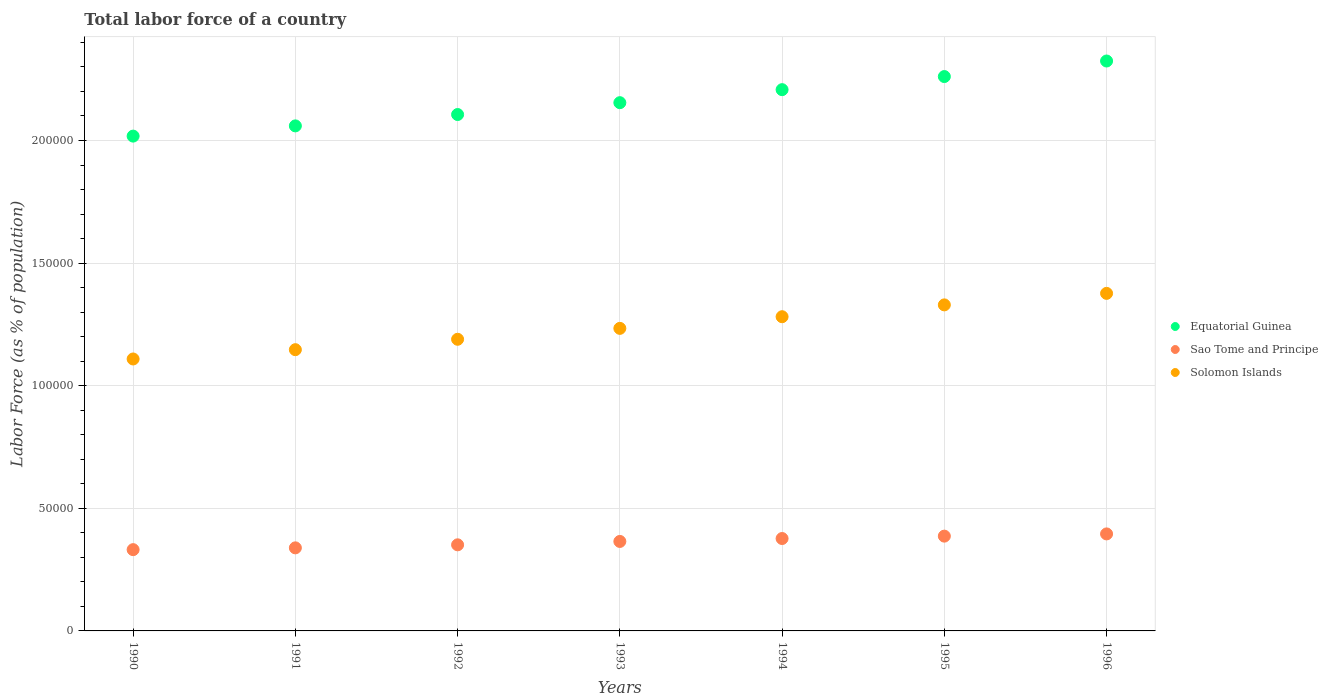How many different coloured dotlines are there?
Give a very brief answer. 3. What is the percentage of labor force in Equatorial Guinea in 1996?
Keep it short and to the point. 2.32e+05. Across all years, what is the maximum percentage of labor force in Solomon Islands?
Your answer should be very brief. 1.38e+05. Across all years, what is the minimum percentage of labor force in Equatorial Guinea?
Your answer should be very brief. 2.02e+05. In which year was the percentage of labor force in Solomon Islands maximum?
Offer a terse response. 1996. In which year was the percentage of labor force in Sao Tome and Principe minimum?
Your response must be concise. 1990. What is the total percentage of labor force in Solomon Islands in the graph?
Your answer should be very brief. 8.67e+05. What is the difference between the percentage of labor force in Equatorial Guinea in 1990 and that in 1994?
Offer a terse response. -1.89e+04. What is the difference between the percentage of labor force in Equatorial Guinea in 1994 and the percentage of labor force in Sao Tome and Principe in 1990?
Ensure brevity in your answer.  1.88e+05. What is the average percentage of labor force in Sao Tome and Principe per year?
Your answer should be very brief. 3.64e+04. In the year 1996, what is the difference between the percentage of labor force in Sao Tome and Principe and percentage of labor force in Solomon Islands?
Your answer should be very brief. -9.81e+04. In how many years, is the percentage of labor force in Sao Tome and Principe greater than 50000 %?
Keep it short and to the point. 0. What is the ratio of the percentage of labor force in Sao Tome and Principe in 1994 to that in 1996?
Ensure brevity in your answer.  0.95. What is the difference between the highest and the second highest percentage of labor force in Sao Tome and Principe?
Ensure brevity in your answer.  905. What is the difference between the highest and the lowest percentage of labor force in Solomon Islands?
Ensure brevity in your answer.  2.68e+04. Is the sum of the percentage of labor force in Solomon Islands in 1993 and 1994 greater than the maximum percentage of labor force in Equatorial Guinea across all years?
Offer a terse response. Yes. Does the percentage of labor force in Equatorial Guinea monotonically increase over the years?
Your answer should be very brief. Yes. Is the percentage of labor force in Sao Tome and Principe strictly less than the percentage of labor force in Solomon Islands over the years?
Provide a succinct answer. Yes. What is the difference between two consecutive major ticks on the Y-axis?
Offer a terse response. 5.00e+04. Are the values on the major ticks of Y-axis written in scientific E-notation?
Keep it short and to the point. No. Does the graph contain any zero values?
Make the answer very short. No. Does the graph contain grids?
Give a very brief answer. Yes. Where does the legend appear in the graph?
Your answer should be compact. Center right. What is the title of the graph?
Give a very brief answer. Total labor force of a country. Does "Slovenia" appear as one of the legend labels in the graph?
Your answer should be very brief. No. What is the label or title of the Y-axis?
Provide a short and direct response. Labor Force (as % of population). What is the Labor Force (as % of population) in Equatorial Guinea in 1990?
Make the answer very short. 2.02e+05. What is the Labor Force (as % of population) in Sao Tome and Principe in 1990?
Offer a terse response. 3.31e+04. What is the Labor Force (as % of population) in Solomon Islands in 1990?
Give a very brief answer. 1.11e+05. What is the Labor Force (as % of population) in Equatorial Guinea in 1991?
Provide a succinct answer. 2.06e+05. What is the Labor Force (as % of population) of Sao Tome and Principe in 1991?
Ensure brevity in your answer.  3.39e+04. What is the Labor Force (as % of population) of Solomon Islands in 1991?
Your answer should be compact. 1.15e+05. What is the Labor Force (as % of population) in Equatorial Guinea in 1992?
Provide a short and direct response. 2.11e+05. What is the Labor Force (as % of population) in Sao Tome and Principe in 1992?
Keep it short and to the point. 3.51e+04. What is the Labor Force (as % of population) in Solomon Islands in 1992?
Offer a terse response. 1.19e+05. What is the Labor Force (as % of population) of Equatorial Guinea in 1993?
Offer a very short reply. 2.15e+05. What is the Labor Force (as % of population) of Sao Tome and Principe in 1993?
Offer a terse response. 3.65e+04. What is the Labor Force (as % of population) in Solomon Islands in 1993?
Your answer should be compact. 1.23e+05. What is the Labor Force (as % of population) of Equatorial Guinea in 1994?
Give a very brief answer. 2.21e+05. What is the Labor Force (as % of population) of Sao Tome and Principe in 1994?
Provide a short and direct response. 3.77e+04. What is the Labor Force (as % of population) of Solomon Islands in 1994?
Your answer should be very brief. 1.28e+05. What is the Labor Force (as % of population) in Equatorial Guinea in 1995?
Provide a short and direct response. 2.26e+05. What is the Labor Force (as % of population) in Sao Tome and Principe in 1995?
Make the answer very short. 3.87e+04. What is the Labor Force (as % of population) of Solomon Islands in 1995?
Make the answer very short. 1.33e+05. What is the Labor Force (as % of population) of Equatorial Guinea in 1996?
Keep it short and to the point. 2.32e+05. What is the Labor Force (as % of population) in Sao Tome and Principe in 1996?
Provide a succinct answer. 3.96e+04. What is the Labor Force (as % of population) of Solomon Islands in 1996?
Your answer should be compact. 1.38e+05. Across all years, what is the maximum Labor Force (as % of population) in Equatorial Guinea?
Offer a terse response. 2.32e+05. Across all years, what is the maximum Labor Force (as % of population) of Sao Tome and Principe?
Ensure brevity in your answer.  3.96e+04. Across all years, what is the maximum Labor Force (as % of population) of Solomon Islands?
Keep it short and to the point. 1.38e+05. Across all years, what is the minimum Labor Force (as % of population) of Equatorial Guinea?
Your response must be concise. 2.02e+05. Across all years, what is the minimum Labor Force (as % of population) in Sao Tome and Principe?
Your answer should be compact. 3.31e+04. Across all years, what is the minimum Labor Force (as % of population) in Solomon Islands?
Offer a very short reply. 1.11e+05. What is the total Labor Force (as % of population) in Equatorial Guinea in the graph?
Offer a very short reply. 1.51e+06. What is the total Labor Force (as % of population) of Sao Tome and Principe in the graph?
Ensure brevity in your answer.  2.55e+05. What is the total Labor Force (as % of population) of Solomon Islands in the graph?
Provide a short and direct response. 8.67e+05. What is the difference between the Labor Force (as % of population) in Equatorial Guinea in 1990 and that in 1991?
Offer a terse response. -4169. What is the difference between the Labor Force (as % of population) of Sao Tome and Principe in 1990 and that in 1991?
Ensure brevity in your answer.  -732. What is the difference between the Labor Force (as % of population) in Solomon Islands in 1990 and that in 1991?
Your response must be concise. -3792. What is the difference between the Labor Force (as % of population) of Equatorial Guinea in 1990 and that in 1992?
Offer a very short reply. -8802. What is the difference between the Labor Force (as % of population) in Sao Tome and Principe in 1990 and that in 1992?
Provide a short and direct response. -1969. What is the difference between the Labor Force (as % of population) of Solomon Islands in 1990 and that in 1992?
Your response must be concise. -8037. What is the difference between the Labor Force (as % of population) in Equatorial Guinea in 1990 and that in 1993?
Your answer should be very brief. -1.36e+04. What is the difference between the Labor Force (as % of population) of Sao Tome and Principe in 1990 and that in 1993?
Make the answer very short. -3347. What is the difference between the Labor Force (as % of population) of Solomon Islands in 1990 and that in 1993?
Your answer should be compact. -1.25e+04. What is the difference between the Labor Force (as % of population) in Equatorial Guinea in 1990 and that in 1994?
Offer a terse response. -1.89e+04. What is the difference between the Labor Force (as % of population) of Sao Tome and Principe in 1990 and that in 1994?
Provide a short and direct response. -4537. What is the difference between the Labor Force (as % of population) of Solomon Islands in 1990 and that in 1994?
Make the answer very short. -1.72e+04. What is the difference between the Labor Force (as % of population) in Equatorial Guinea in 1990 and that in 1995?
Your answer should be very brief. -2.43e+04. What is the difference between the Labor Force (as % of population) of Sao Tome and Principe in 1990 and that in 1995?
Provide a succinct answer. -5513. What is the difference between the Labor Force (as % of population) in Solomon Islands in 1990 and that in 1995?
Offer a terse response. -2.21e+04. What is the difference between the Labor Force (as % of population) in Equatorial Guinea in 1990 and that in 1996?
Make the answer very short. -3.06e+04. What is the difference between the Labor Force (as % of population) of Sao Tome and Principe in 1990 and that in 1996?
Your answer should be compact. -6418. What is the difference between the Labor Force (as % of population) in Solomon Islands in 1990 and that in 1996?
Offer a very short reply. -2.68e+04. What is the difference between the Labor Force (as % of population) in Equatorial Guinea in 1991 and that in 1992?
Provide a succinct answer. -4633. What is the difference between the Labor Force (as % of population) in Sao Tome and Principe in 1991 and that in 1992?
Your response must be concise. -1237. What is the difference between the Labor Force (as % of population) in Solomon Islands in 1991 and that in 1992?
Offer a very short reply. -4245. What is the difference between the Labor Force (as % of population) in Equatorial Guinea in 1991 and that in 1993?
Your answer should be compact. -9464. What is the difference between the Labor Force (as % of population) in Sao Tome and Principe in 1991 and that in 1993?
Give a very brief answer. -2615. What is the difference between the Labor Force (as % of population) in Solomon Islands in 1991 and that in 1993?
Ensure brevity in your answer.  -8693. What is the difference between the Labor Force (as % of population) of Equatorial Guinea in 1991 and that in 1994?
Keep it short and to the point. -1.48e+04. What is the difference between the Labor Force (as % of population) of Sao Tome and Principe in 1991 and that in 1994?
Your answer should be very brief. -3805. What is the difference between the Labor Force (as % of population) of Solomon Islands in 1991 and that in 1994?
Provide a succinct answer. -1.34e+04. What is the difference between the Labor Force (as % of population) in Equatorial Guinea in 1991 and that in 1995?
Provide a succinct answer. -2.01e+04. What is the difference between the Labor Force (as % of population) in Sao Tome and Principe in 1991 and that in 1995?
Your response must be concise. -4781. What is the difference between the Labor Force (as % of population) in Solomon Islands in 1991 and that in 1995?
Ensure brevity in your answer.  -1.83e+04. What is the difference between the Labor Force (as % of population) in Equatorial Guinea in 1991 and that in 1996?
Your response must be concise. -2.65e+04. What is the difference between the Labor Force (as % of population) in Sao Tome and Principe in 1991 and that in 1996?
Make the answer very short. -5686. What is the difference between the Labor Force (as % of population) in Solomon Islands in 1991 and that in 1996?
Offer a very short reply. -2.30e+04. What is the difference between the Labor Force (as % of population) in Equatorial Guinea in 1992 and that in 1993?
Make the answer very short. -4831. What is the difference between the Labor Force (as % of population) in Sao Tome and Principe in 1992 and that in 1993?
Your answer should be very brief. -1378. What is the difference between the Labor Force (as % of population) in Solomon Islands in 1992 and that in 1993?
Provide a succinct answer. -4448. What is the difference between the Labor Force (as % of population) of Equatorial Guinea in 1992 and that in 1994?
Offer a terse response. -1.01e+04. What is the difference between the Labor Force (as % of population) of Sao Tome and Principe in 1992 and that in 1994?
Offer a very short reply. -2568. What is the difference between the Labor Force (as % of population) of Solomon Islands in 1992 and that in 1994?
Provide a short and direct response. -9199. What is the difference between the Labor Force (as % of population) in Equatorial Guinea in 1992 and that in 1995?
Make the answer very short. -1.55e+04. What is the difference between the Labor Force (as % of population) in Sao Tome and Principe in 1992 and that in 1995?
Ensure brevity in your answer.  -3544. What is the difference between the Labor Force (as % of population) of Solomon Islands in 1992 and that in 1995?
Ensure brevity in your answer.  -1.40e+04. What is the difference between the Labor Force (as % of population) in Equatorial Guinea in 1992 and that in 1996?
Keep it short and to the point. -2.18e+04. What is the difference between the Labor Force (as % of population) in Sao Tome and Principe in 1992 and that in 1996?
Give a very brief answer. -4449. What is the difference between the Labor Force (as % of population) of Solomon Islands in 1992 and that in 1996?
Offer a terse response. -1.87e+04. What is the difference between the Labor Force (as % of population) of Equatorial Guinea in 1993 and that in 1994?
Make the answer very short. -5308. What is the difference between the Labor Force (as % of population) in Sao Tome and Principe in 1993 and that in 1994?
Offer a terse response. -1190. What is the difference between the Labor Force (as % of population) of Solomon Islands in 1993 and that in 1994?
Provide a succinct answer. -4751. What is the difference between the Labor Force (as % of population) of Equatorial Guinea in 1993 and that in 1995?
Offer a terse response. -1.07e+04. What is the difference between the Labor Force (as % of population) of Sao Tome and Principe in 1993 and that in 1995?
Your answer should be very brief. -2166. What is the difference between the Labor Force (as % of population) in Solomon Islands in 1993 and that in 1995?
Keep it short and to the point. -9576. What is the difference between the Labor Force (as % of population) of Equatorial Guinea in 1993 and that in 1996?
Provide a succinct answer. -1.70e+04. What is the difference between the Labor Force (as % of population) of Sao Tome and Principe in 1993 and that in 1996?
Make the answer very short. -3071. What is the difference between the Labor Force (as % of population) of Solomon Islands in 1993 and that in 1996?
Your answer should be very brief. -1.43e+04. What is the difference between the Labor Force (as % of population) in Equatorial Guinea in 1994 and that in 1995?
Give a very brief answer. -5345. What is the difference between the Labor Force (as % of population) in Sao Tome and Principe in 1994 and that in 1995?
Ensure brevity in your answer.  -976. What is the difference between the Labor Force (as % of population) in Solomon Islands in 1994 and that in 1995?
Your answer should be very brief. -4825. What is the difference between the Labor Force (as % of population) of Equatorial Guinea in 1994 and that in 1996?
Keep it short and to the point. -1.17e+04. What is the difference between the Labor Force (as % of population) in Sao Tome and Principe in 1994 and that in 1996?
Provide a succinct answer. -1881. What is the difference between the Labor Force (as % of population) of Solomon Islands in 1994 and that in 1996?
Offer a terse response. -9523. What is the difference between the Labor Force (as % of population) of Equatorial Guinea in 1995 and that in 1996?
Keep it short and to the point. -6343. What is the difference between the Labor Force (as % of population) in Sao Tome and Principe in 1995 and that in 1996?
Offer a very short reply. -905. What is the difference between the Labor Force (as % of population) in Solomon Islands in 1995 and that in 1996?
Keep it short and to the point. -4698. What is the difference between the Labor Force (as % of population) in Equatorial Guinea in 1990 and the Labor Force (as % of population) in Sao Tome and Principe in 1991?
Provide a succinct answer. 1.68e+05. What is the difference between the Labor Force (as % of population) in Equatorial Guinea in 1990 and the Labor Force (as % of population) in Solomon Islands in 1991?
Keep it short and to the point. 8.71e+04. What is the difference between the Labor Force (as % of population) in Sao Tome and Principe in 1990 and the Labor Force (as % of population) in Solomon Islands in 1991?
Provide a short and direct response. -8.16e+04. What is the difference between the Labor Force (as % of population) in Equatorial Guinea in 1990 and the Labor Force (as % of population) in Sao Tome and Principe in 1992?
Make the answer very short. 1.67e+05. What is the difference between the Labor Force (as % of population) of Equatorial Guinea in 1990 and the Labor Force (as % of population) of Solomon Islands in 1992?
Give a very brief answer. 8.29e+04. What is the difference between the Labor Force (as % of population) in Sao Tome and Principe in 1990 and the Labor Force (as % of population) in Solomon Islands in 1992?
Give a very brief answer. -8.58e+04. What is the difference between the Labor Force (as % of population) of Equatorial Guinea in 1990 and the Labor Force (as % of population) of Sao Tome and Principe in 1993?
Your answer should be compact. 1.65e+05. What is the difference between the Labor Force (as % of population) of Equatorial Guinea in 1990 and the Labor Force (as % of population) of Solomon Islands in 1993?
Provide a short and direct response. 7.84e+04. What is the difference between the Labor Force (as % of population) in Sao Tome and Principe in 1990 and the Labor Force (as % of population) in Solomon Islands in 1993?
Ensure brevity in your answer.  -9.02e+04. What is the difference between the Labor Force (as % of population) in Equatorial Guinea in 1990 and the Labor Force (as % of population) in Sao Tome and Principe in 1994?
Your response must be concise. 1.64e+05. What is the difference between the Labor Force (as % of population) of Equatorial Guinea in 1990 and the Labor Force (as % of population) of Solomon Islands in 1994?
Ensure brevity in your answer.  7.37e+04. What is the difference between the Labor Force (as % of population) of Sao Tome and Principe in 1990 and the Labor Force (as % of population) of Solomon Islands in 1994?
Offer a very short reply. -9.50e+04. What is the difference between the Labor Force (as % of population) of Equatorial Guinea in 1990 and the Labor Force (as % of population) of Sao Tome and Principe in 1995?
Provide a short and direct response. 1.63e+05. What is the difference between the Labor Force (as % of population) of Equatorial Guinea in 1990 and the Labor Force (as % of population) of Solomon Islands in 1995?
Offer a terse response. 6.88e+04. What is the difference between the Labor Force (as % of population) in Sao Tome and Principe in 1990 and the Labor Force (as % of population) in Solomon Islands in 1995?
Ensure brevity in your answer.  -9.98e+04. What is the difference between the Labor Force (as % of population) of Equatorial Guinea in 1990 and the Labor Force (as % of population) of Sao Tome and Principe in 1996?
Provide a short and direct response. 1.62e+05. What is the difference between the Labor Force (as % of population) in Equatorial Guinea in 1990 and the Labor Force (as % of population) in Solomon Islands in 1996?
Give a very brief answer. 6.41e+04. What is the difference between the Labor Force (as % of population) of Sao Tome and Principe in 1990 and the Labor Force (as % of population) of Solomon Islands in 1996?
Your answer should be compact. -1.05e+05. What is the difference between the Labor Force (as % of population) in Equatorial Guinea in 1991 and the Labor Force (as % of population) in Sao Tome and Principe in 1992?
Your answer should be very brief. 1.71e+05. What is the difference between the Labor Force (as % of population) in Equatorial Guinea in 1991 and the Labor Force (as % of population) in Solomon Islands in 1992?
Make the answer very short. 8.70e+04. What is the difference between the Labor Force (as % of population) in Sao Tome and Principe in 1991 and the Labor Force (as % of population) in Solomon Islands in 1992?
Provide a short and direct response. -8.51e+04. What is the difference between the Labor Force (as % of population) in Equatorial Guinea in 1991 and the Labor Force (as % of population) in Sao Tome and Principe in 1993?
Your answer should be very brief. 1.69e+05. What is the difference between the Labor Force (as % of population) of Equatorial Guinea in 1991 and the Labor Force (as % of population) of Solomon Islands in 1993?
Your answer should be very brief. 8.26e+04. What is the difference between the Labor Force (as % of population) of Sao Tome and Principe in 1991 and the Labor Force (as % of population) of Solomon Islands in 1993?
Keep it short and to the point. -8.95e+04. What is the difference between the Labor Force (as % of population) of Equatorial Guinea in 1991 and the Labor Force (as % of population) of Sao Tome and Principe in 1994?
Your answer should be very brief. 1.68e+05. What is the difference between the Labor Force (as % of population) of Equatorial Guinea in 1991 and the Labor Force (as % of population) of Solomon Islands in 1994?
Ensure brevity in your answer.  7.78e+04. What is the difference between the Labor Force (as % of population) in Sao Tome and Principe in 1991 and the Labor Force (as % of population) in Solomon Islands in 1994?
Provide a short and direct response. -9.43e+04. What is the difference between the Labor Force (as % of population) in Equatorial Guinea in 1991 and the Labor Force (as % of population) in Sao Tome and Principe in 1995?
Ensure brevity in your answer.  1.67e+05. What is the difference between the Labor Force (as % of population) of Equatorial Guinea in 1991 and the Labor Force (as % of population) of Solomon Islands in 1995?
Your response must be concise. 7.30e+04. What is the difference between the Labor Force (as % of population) in Sao Tome and Principe in 1991 and the Labor Force (as % of population) in Solomon Islands in 1995?
Provide a short and direct response. -9.91e+04. What is the difference between the Labor Force (as % of population) of Equatorial Guinea in 1991 and the Labor Force (as % of population) of Sao Tome and Principe in 1996?
Keep it short and to the point. 1.66e+05. What is the difference between the Labor Force (as % of population) in Equatorial Guinea in 1991 and the Labor Force (as % of population) in Solomon Islands in 1996?
Make the answer very short. 6.83e+04. What is the difference between the Labor Force (as % of population) of Sao Tome and Principe in 1991 and the Labor Force (as % of population) of Solomon Islands in 1996?
Your answer should be compact. -1.04e+05. What is the difference between the Labor Force (as % of population) of Equatorial Guinea in 1992 and the Labor Force (as % of population) of Sao Tome and Principe in 1993?
Provide a short and direct response. 1.74e+05. What is the difference between the Labor Force (as % of population) in Equatorial Guinea in 1992 and the Labor Force (as % of population) in Solomon Islands in 1993?
Give a very brief answer. 8.72e+04. What is the difference between the Labor Force (as % of population) of Sao Tome and Principe in 1992 and the Labor Force (as % of population) of Solomon Islands in 1993?
Your answer should be compact. -8.83e+04. What is the difference between the Labor Force (as % of population) of Equatorial Guinea in 1992 and the Labor Force (as % of population) of Sao Tome and Principe in 1994?
Your answer should be compact. 1.73e+05. What is the difference between the Labor Force (as % of population) in Equatorial Guinea in 1992 and the Labor Force (as % of population) in Solomon Islands in 1994?
Give a very brief answer. 8.25e+04. What is the difference between the Labor Force (as % of population) of Sao Tome and Principe in 1992 and the Labor Force (as % of population) of Solomon Islands in 1994?
Provide a short and direct response. -9.30e+04. What is the difference between the Labor Force (as % of population) of Equatorial Guinea in 1992 and the Labor Force (as % of population) of Sao Tome and Principe in 1995?
Provide a succinct answer. 1.72e+05. What is the difference between the Labor Force (as % of population) of Equatorial Guinea in 1992 and the Labor Force (as % of population) of Solomon Islands in 1995?
Provide a succinct answer. 7.76e+04. What is the difference between the Labor Force (as % of population) of Sao Tome and Principe in 1992 and the Labor Force (as % of population) of Solomon Islands in 1995?
Keep it short and to the point. -9.79e+04. What is the difference between the Labor Force (as % of population) in Equatorial Guinea in 1992 and the Labor Force (as % of population) in Sao Tome and Principe in 1996?
Provide a succinct answer. 1.71e+05. What is the difference between the Labor Force (as % of population) in Equatorial Guinea in 1992 and the Labor Force (as % of population) in Solomon Islands in 1996?
Offer a very short reply. 7.29e+04. What is the difference between the Labor Force (as % of population) in Sao Tome and Principe in 1992 and the Labor Force (as % of population) in Solomon Islands in 1996?
Your answer should be very brief. -1.03e+05. What is the difference between the Labor Force (as % of population) in Equatorial Guinea in 1993 and the Labor Force (as % of population) in Sao Tome and Principe in 1994?
Give a very brief answer. 1.78e+05. What is the difference between the Labor Force (as % of population) in Equatorial Guinea in 1993 and the Labor Force (as % of population) in Solomon Islands in 1994?
Ensure brevity in your answer.  8.73e+04. What is the difference between the Labor Force (as % of population) of Sao Tome and Principe in 1993 and the Labor Force (as % of population) of Solomon Islands in 1994?
Provide a succinct answer. -9.16e+04. What is the difference between the Labor Force (as % of population) of Equatorial Guinea in 1993 and the Labor Force (as % of population) of Sao Tome and Principe in 1995?
Your answer should be very brief. 1.77e+05. What is the difference between the Labor Force (as % of population) in Equatorial Guinea in 1993 and the Labor Force (as % of population) in Solomon Islands in 1995?
Offer a terse response. 8.25e+04. What is the difference between the Labor Force (as % of population) of Sao Tome and Principe in 1993 and the Labor Force (as % of population) of Solomon Islands in 1995?
Keep it short and to the point. -9.65e+04. What is the difference between the Labor Force (as % of population) of Equatorial Guinea in 1993 and the Labor Force (as % of population) of Sao Tome and Principe in 1996?
Your answer should be very brief. 1.76e+05. What is the difference between the Labor Force (as % of population) in Equatorial Guinea in 1993 and the Labor Force (as % of population) in Solomon Islands in 1996?
Provide a succinct answer. 7.78e+04. What is the difference between the Labor Force (as % of population) in Sao Tome and Principe in 1993 and the Labor Force (as % of population) in Solomon Islands in 1996?
Ensure brevity in your answer.  -1.01e+05. What is the difference between the Labor Force (as % of population) of Equatorial Guinea in 1994 and the Labor Force (as % of population) of Sao Tome and Principe in 1995?
Make the answer very short. 1.82e+05. What is the difference between the Labor Force (as % of population) of Equatorial Guinea in 1994 and the Labor Force (as % of population) of Solomon Islands in 1995?
Provide a succinct answer. 8.78e+04. What is the difference between the Labor Force (as % of population) of Sao Tome and Principe in 1994 and the Labor Force (as % of population) of Solomon Islands in 1995?
Ensure brevity in your answer.  -9.53e+04. What is the difference between the Labor Force (as % of population) of Equatorial Guinea in 1994 and the Labor Force (as % of population) of Sao Tome and Principe in 1996?
Your answer should be very brief. 1.81e+05. What is the difference between the Labor Force (as % of population) of Equatorial Guinea in 1994 and the Labor Force (as % of population) of Solomon Islands in 1996?
Keep it short and to the point. 8.31e+04. What is the difference between the Labor Force (as % of population) of Sao Tome and Principe in 1994 and the Labor Force (as % of population) of Solomon Islands in 1996?
Your answer should be very brief. -1.00e+05. What is the difference between the Labor Force (as % of population) of Equatorial Guinea in 1995 and the Labor Force (as % of population) of Sao Tome and Principe in 1996?
Your answer should be very brief. 1.87e+05. What is the difference between the Labor Force (as % of population) of Equatorial Guinea in 1995 and the Labor Force (as % of population) of Solomon Islands in 1996?
Offer a very short reply. 8.84e+04. What is the difference between the Labor Force (as % of population) in Sao Tome and Principe in 1995 and the Labor Force (as % of population) in Solomon Islands in 1996?
Offer a very short reply. -9.90e+04. What is the average Labor Force (as % of population) of Equatorial Guinea per year?
Ensure brevity in your answer.  2.16e+05. What is the average Labor Force (as % of population) of Sao Tome and Principe per year?
Provide a short and direct response. 3.64e+04. What is the average Labor Force (as % of population) of Solomon Islands per year?
Offer a terse response. 1.24e+05. In the year 1990, what is the difference between the Labor Force (as % of population) of Equatorial Guinea and Labor Force (as % of population) of Sao Tome and Principe?
Offer a very short reply. 1.69e+05. In the year 1990, what is the difference between the Labor Force (as % of population) of Equatorial Guinea and Labor Force (as % of population) of Solomon Islands?
Ensure brevity in your answer.  9.09e+04. In the year 1990, what is the difference between the Labor Force (as % of population) of Sao Tome and Principe and Labor Force (as % of population) of Solomon Islands?
Your answer should be compact. -7.78e+04. In the year 1991, what is the difference between the Labor Force (as % of population) of Equatorial Guinea and Labor Force (as % of population) of Sao Tome and Principe?
Give a very brief answer. 1.72e+05. In the year 1991, what is the difference between the Labor Force (as % of population) of Equatorial Guinea and Labor Force (as % of population) of Solomon Islands?
Your answer should be compact. 9.13e+04. In the year 1991, what is the difference between the Labor Force (as % of population) in Sao Tome and Principe and Labor Force (as % of population) in Solomon Islands?
Give a very brief answer. -8.08e+04. In the year 1992, what is the difference between the Labor Force (as % of population) of Equatorial Guinea and Labor Force (as % of population) of Sao Tome and Principe?
Make the answer very short. 1.75e+05. In the year 1992, what is the difference between the Labor Force (as % of population) of Equatorial Guinea and Labor Force (as % of population) of Solomon Islands?
Your answer should be compact. 9.17e+04. In the year 1992, what is the difference between the Labor Force (as % of population) of Sao Tome and Principe and Labor Force (as % of population) of Solomon Islands?
Provide a short and direct response. -8.38e+04. In the year 1993, what is the difference between the Labor Force (as % of population) in Equatorial Guinea and Labor Force (as % of population) in Sao Tome and Principe?
Provide a short and direct response. 1.79e+05. In the year 1993, what is the difference between the Labor Force (as % of population) of Equatorial Guinea and Labor Force (as % of population) of Solomon Islands?
Your answer should be compact. 9.20e+04. In the year 1993, what is the difference between the Labor Force (as % of population) of Sao Tome and Principe and Labor Force (as % of population) of Solomon Islands?
Offer a very short reply. -8.69e+04. In the year 1994, what is the difference between the Labor Force (as % of population) in Equatorial Guinea and Labor Force (as % of population) in Sao Tome and Principe?
Offer a terse response. 1.83e+05. In the year 1994, what is the difference between the Labor Force (as % of population) in Equatorial Guinea and Labor Force (as % of population) in Solomon Islands?
Your answer should be very brief. 9.26e+04. In the year 1994, what is the difference between the Labor Force (as % of population) in Sao Tome and Principe and Labor Force (as % of population) in Solomon Islands?
Provide a succinct answer. -9.05e+04. In the year 1995, what is the difference between the Labor Force (as % of population) in Equatorial Guinea and Labor Force (as % of population) in Sao Tome and Principe?
Your answer should be compact. 1.87e+05. In the year 1995, what is the difference between the Labor Force (as % of population) of Equatorial Guinea and Labor Force (as % of population) of Solomon Islands?
Make the answer very short. 9.31e+04. In the year 1995, what is the difference between the Labor Force (as % of population) in Sao Tome and Principe and Labor Force (as % of population) in Solomon Islands?
Make the answer very short. -9.43e+04. In the year 1996, what is the difference between the Labor Force (as % of population) of Equatorial Guinea and Labor Force (as % of population) of Sao Tome and Principe?
Keep it short and to the point. 1.93e+05. In the year 1996, what is the difference between the Labor Force (as % of population) in Equatorial Guinea and Labor Force (as % of population) in Solomon Islands?
Offer a terse response. 9.48e+04. In the year 1996, what is the difference between the Labor Force (as % of population) of Sao Tome and Principe and Labor Force (as % of population) of Solomon Islands?
Make the answer very short. -9.81e+04. What is the ratio of the Labor Force (as % of population) of Equatorial Guinea in 1990 to that in 1991?
Your answer should be compact. 0.98. What is the ratio of the Labor Force (as % of population) of Sao Tome and Principe in 1990 to that in 1991?
Provide a succinct answer. 0.98. What is the ratio of the Labor Force (as % of population) of Solomon Islands in 1990 to that in 1991?
Your response must be concise. 0.97. What is the ratio of the Labor Force (as % of population) of Equatorial Guinea in 1990 to that in 1992?
Your answer should be compact. 0.96. What is the ratio of the Labor Force (as % of population) in Sao Tome and Principe in 1990 to that in 1992?
Make the answer very short. 0.94. What is the ratio of the Labor Force (as % of population) of Solomon Islands in 1990 to that in 1992?
Your response must be concise. 0.93. What is the ratio of the Labor Force (as % of population) in Equatorial Guinea in 1990 to that in 1993?
Ensure brevity in your answer.  0.94. What is the ratio of the Labor Force (as % of population) of Sao Tome and Principe in 1990 to that in 1993?
Your response must be concise. 0.91. What is the ratio of the Labor Force (as % of population) of Solomon Islands in 1990 to that in 1993?
Your answer should be compact. 0.9. What is the ratio of the Labor Force (as % of population) in Equatorial Guinea in 1990 to that in 1994?
Your response must be concise. 0.91. What is the ratio of the Labor Force (as % of population) of Sao Tome and Principe in 1990 to that in 1994?
Ensure brevity in your answer.  0.88. What is the ratio of the Labor Force (as % of population) of Solomon Islands in 1990 to that in 1994?
Provide a short and direct response. 0.87. What is the ratio of the Labor Force (as % of population) in Equatorial Guinea in 1990 to that in 1995?
Your response must be concise. 0.89. What is the ratio of the Labor Force (as % of population) in Sao Tome and Principe in 1990 to that in 1995?
Your answer should be compact. 0.86. What is the ratio of the Labor Force (as % of population) in Solomon Islands in 1990 to that in 1995?
Offer a very short reply. 0.83. What is the ratio of the Labor Force (as % of population) of Equatorial Guinea in 1990 to that in 1996?
Provide a succinct answer. 0.87. What is the ratio of the Labor Force (as % of population) in Sao Tome and Principe in 1990 to that in 1996?
Provide a short and direct response. 0.84. What is the ratio of the Labor Force (as % of population) of Solomon Islands in 1990 to that in 1996?
Offer a very short reply. 0.81. What is the ratio of the Labor Force (as % of population) of Equatorial Guinea in 1991 to that in 1992?
Your answer should be very brief. 0.98. What is the ratio of the Labor Force (as % of population) of Sao Tome and Principe in 1991 to that in 1992?
Make the answer very short. 0.96. What is the ratio of the Labor Force (as % of population) of Equatorial Guinea in 1991 to that in 1993?
Your response must be concise. 0.96. What is the ratio of the Labor Force (as % of population) of Sao Tome and Principe in 1991 to that in 1993?
Provide a short and direct response. 0.93. What is the ratio of the Labor Force (as % of population) in Solomon Islands in 1991 to that in 1993?
Make the answer very short. 0.93. What is the ratio of the Labor Force (as % of population) in Equatorial Guinea in 1991 to that in 1994?
Make the answer very short. 0.93. What is the ratio of the Labor Force (as % of population) of Sao Tome and Principe in 1991 to that in 1994?
Give a very brief answer. 0.9. What is the ratio of the Labor Force (as % of population) in Solomon Islands in 1991 to that in 1994?
Provide a short and direct response. 0.9. What is the ratio of the Labor Force (as % of population) in Equatorial Guinea in 1991 to that in 1995?
Ensure brevity in your answer.  0.91. What is the ratio of the Labor Force (as % of population) of Sao Tome and Principe in 1991 to that in 1995?
Your answer should be compact. 0.88. What is the ratio of the Labor Force (as % of population) of Solomon Islands in 1991 to that in 1995?
Keep it short and to the point. 0.86. What is the ratio of the Labor Force (as % of population) in Equatorial Guinea in 1991 to that in 1996?
Provide a short and direct response. 0.89. What is the ratio of the Labor Force (as % of population) of Sao Tome and Principe in 1991 to that in 1996?
Offer a terse response. 0.86. What is the ratio of the Labor Force (as % of population) of Solomon Islands in 1991 to that in 1996?
Offer a very short reply. 0.83. What is the ratio of the Labor Force (as % of population) in Equatorial Guinea in 1992 to that in 1993?
Keep it short and to the point. 0.98. What is the ratio of the Labor Force (as % of population) in Sao Tome and Principe in 1992 to that in 1993?
Offer a terse response. 0.96. What is the ratio of the Labor Force (as % of population) of Solomon Islands in 1992 to that in 1993?
Offer a very short reply. 0.96. What is the ratio of the Labor Force (as % of population) of Equatorial Guinea in 1992 to that in 1994?
Your answer should be very brief. 0.95. What is the ratio of the Labor Force (as % of population) of Sao Tome and Principe in 1992 to that in 1994?
Your answer should be very brief. 0.93. What is the ratio of the Labor Force (as % of population) of Solomon Islands in 1992 to that in 1994?
Give a very brief answer. 0.93. What is the ratio of the Labor Force (as % of population) of Equatorial Guinea in 1992 to that in 1995?
Give a very brief answer. 0.93. What is the ratio of the Labor Force (as % of population) in Sao Tome and Principe in 1992 to that in 1995?
Make the answer very short. 0.91. What is the ratio of the Labor Force (as % of population) of Solomon Islands in 1992 to that in 1995?
Provide a succinct answer. 0.89. What is the ratio of the Labor Force (as % of population) in Equatorial Guinea in 1992 to that in 1996?
Your answer should be very brief. 0.91. What is the ratio of the Labor Force (as % of population) of Sao Tome and Principe in 1992 to that in 1996?
Make the answer very short. 0.89. What is the ratio of the Labor Force (as % of population) of Solomon Islands in 1992 to that in 1996?
Your answer should be very brief. 0.86. What is the ratio of the Labor Force (as % of population) of Sao Tome and Principe in 1993 to that in 1994?
Your answer should be very brief. 0.97. What is the ratio of the Labor Force (as % of population) in Solomon Islands in 1993 to that in 1994?
Keep it short and to the point. 0.96. What is the ratio of the Labor Force (as % of population) in Equatorial Guinea in 1993 to that in 1995?
Provide a short and direct response. 0.95. What is the ratio of the Labor Force (as % of population) in Sao Tome and Principe in 1993 to that in 1995?
Give a very brief answer. 0.94. What is the ratio of the Labor Force (as % of population) of Solomon Islands in 1993 to that in 1995?
Your response must be concise. 0.93. What is the ratio of the Labor Force (as % of population) in Equatorial Guinea in 1993 to that in 1996?
Ensure brevity in your answer.  0.93. What is the ratio of the Labor Force (as % of population) in Sao Tome and Principe in 1993 to that in 1996?
Provide a succinct answer. 0.92. What is the ratio of the Labor Force (as % of population) in Solomon Islands in 1993 to that in 1996?
Your answer should be compact. 0.9. What is the ratio of the Labor Force (as % of population) in Equatorial Guinea in 1994 to that in 1995?
Make the answer very short. 0.98. What is the ratio of the Labor Force (as % of population) in Sao Tome and Principe in 1994 to that in 1995?
Ensure brevity in your answer.  0.97. What is the ratio of the Labor Force (as % of population) in Solomon Islands in 1994 to that in 1995?
Your answer should be very brief. 0.96. What is the ratio of the Labor Force (as % of population) in Equatorial Guinea in 1994 to that in 1996?
Offer a terse response. 0.95. What is the ratio of the Labor Force (as % of population) of Sao Tome and Principe in 1994 to that in 1996?
Ensure brevity in your answer.  0.95. What is the ratio of the Labor Force (as % of population) of Solomon Islands in 1994 to that in 1996?
Your response must be concise. 0.93. What is the ratio of the Labor Force (as % of population) of Equatorial Guinea in 1995 to that in 1996?
Keep it short and to the point. 0.97. What is the ratio of the Labor Force (as % of population) of Sao Tome and Principe in 1995 to that in 1996?
Your answer should be very brief. 0.98. What is the ratio of the Labor Force (as % of population) of Solomon Islands in 1995 to that in 1996?
Your answer should be very brief. 0.97. What is the difference between the highest and the second highest Labor Force (as % of population) of Equatorial Guinea?
Keep it short and to the point. 6343. What is the difference between the highest and the second highest Labor Force (as % of population) in Sao Tome and Principe?
Give a very brief answer. 905. What is the difference between the highest and the second highest Labor Force (as % of population) in Solomon Islands?
Your response must be concise. 4698. What is the difference between the highest and the lowest Labor Force (as % of population) in Equatorial Guinea?
Provide a succinct answer. 3.06e+04. What is the difference between the highest and the lowest Labor Force (as % of population) of Sao Tome and Principe?
Provide a succinct answer. 6418. What is the difference between the highest and the lowest Labor Force (as % of population) of Solomon Islands?
Keep it short and to the point. 2.68e+04. 